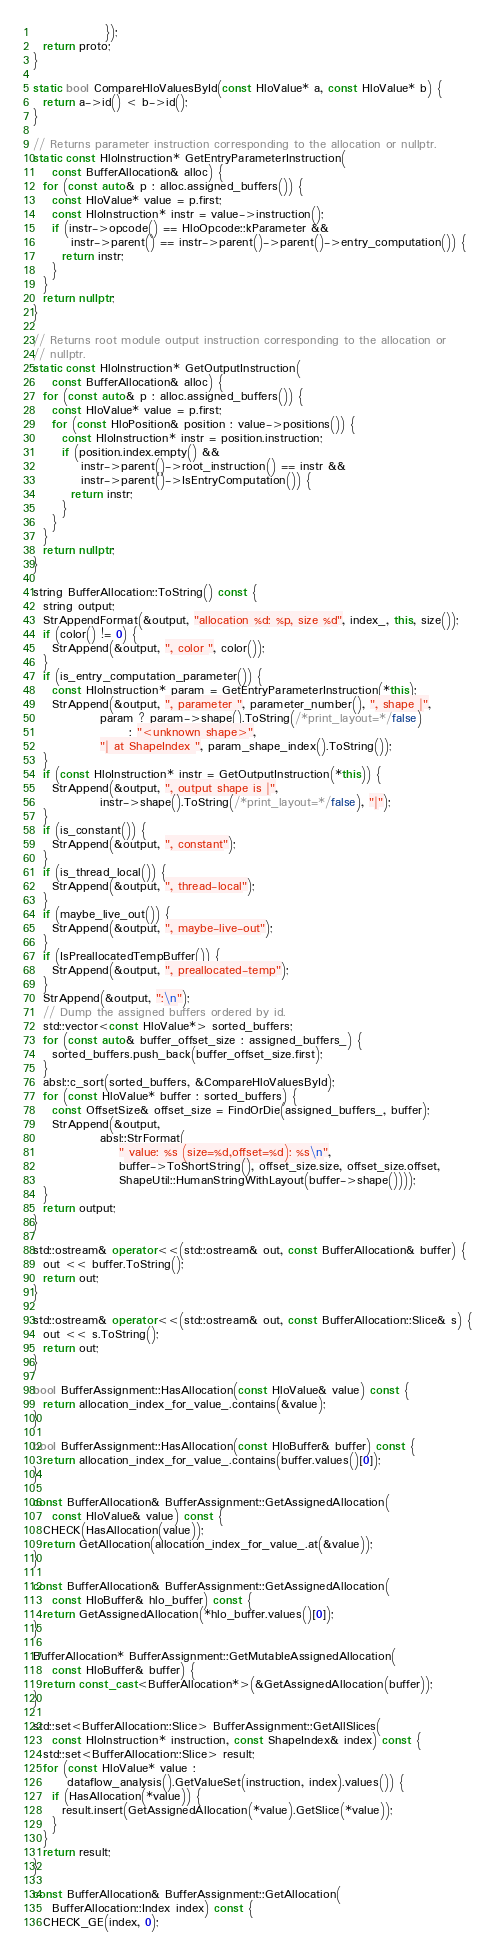<code> <loc_0><loc_0><loc_500><loc_500><_C++_>               });
  return proto;
}

static bool CompareHloValuesById(const HloValue* a, const HloValue* b) {
  return a->id() < b->id();
}

// Returns parameter instruction corresponding to the allocation or nullptr.
static const HloInstruction* GetEntryParameterInstruction(
    const BufferAllocation& alloc) {
  for (const auto& p : alloc.assigned_buffers()) {
    const HloValue* value = p.first;
    const HloInstruction* instr = value->instruction();
    if (instr->opcode() == HloOpcode::kParameter &&
        instr->parent() == instr->parent()->parent()->entry_computation()) {
      return instr;
    }
  }
  return nullptr;
}

// Returns root module output instruction corresponding to the allocation or
// nullptr.
static const HloInstruction* GetOutputInstruction(
    const BufferAllocation& alloc) {
  for (const auto& p : alloc.assigned_buffers()) {
    const HloValue* value = p.first;
    for (const HloPosition& position : value->positions()) {
      const HloInstruction* instr = position.instruction;
      if (position.index.empty() &&
          instr->parent()->root_instruction() == instr &&
          instr->parent()->IsEntryComputation()) {
        return instr;
      }
    }
  }
  return nullptr;
}

string BufferAllocation::ToString() const {
  string output;
  StrAppendFormat(&output, "allocation %d: %p, size %d", index_, this, size());
  if (color() != 0) {
    StrAppend(&output, ", color ", color());
  }
  if (is_entry_computation_parameter()) {
    const HloInstruction* param = GetEntryParameterInstruction(*this);
    StrAppend(&output, ", parameter ", parameter_number(), ", shape |",
              param ? param->shape().ToString(/*print_layout=*/false)
                    : "<unknown shape>",
              "| at ShapeIndex ", param_shape_index().ToString());
  }
  if (const HloInstruction* instr = GetOutputInstruction(*this)) {
    StrAppend(&output, ", output shape is |",
              instr->shape().ToString(/*print_layout=*/false), "|");
  }
  if (is_constant()) {
    StrAppend(&output, ", constant");
  }
  if (is_thread_local()) {
    StrAppend(&output, ", thread-local");
  }
  if (maybe_live_out()) {
    StrAppend(&output, ", maybe-live-out");
  }
  if (IsPreallocatedTempBuffer()) {
    StrAppend(&output, ", preallocated-temp");
  }
  StrAppend(&output, ":\n");
  // Dump the assigned buffers ordered by id.
  std::vector<const HloValue*> sorted_buffers;
  for (const auto& buffer_offset_size : assigned_buffers_) {
    sorted_buffers.push_back(buffer_offset_size.first);
  }
  absl::c_sort(sorted_buffers, &CompareHloValuesById);
  for (const HloValue* buffer : sorted_buffers) {
    const OffsetSize& offset_size = FindOrDie(assigned_buffers_, buffer);
    StrAppend(&output,
              absl::StrFormat(
                  " value: %s (size=%d,offset=%d): %s\n",
                  buffer->ToShortString(), offset_size.size, offset_size.offset,
                  ShapeUtil::HumanStringWithLayout(buffer->shape())));
  }
  return output;
}

std::ostream& operator<<(std::ostream& out, const BufferAllocation& buffer) {
  out << buffer.ToString();
  return out;
}

std::ostream& operator<<(std::ostream& out, const BufferAllocation::Slice& s) {
  out << s.ToString();
  return out;
}

bool BufferAssignment::HasAllocation(const HloValue& value) const {
  return allocation_index_for_value_.contains(&value);
}

bool BufferAssignment::HasAllocation(const HloBuffer& buffer) const {
  return allocation_index_for_value_.contains(buffer.values()[0]);
}

const BufferAllocation& BufferAssignment::GetAssignedAllocation(
    const HloValue& value) const {
  CHECK(HasAllocation(value));
  return GetAllocation(allocation_index_for_value_.at(&value));
}

const BufferAllocation& BufferAssignment::GetAssignedAllocation(
    const HloBuffer& hlo_buffer) const {
  return GetAssignedAllocation(*hlo_buffer.values()[0]);
}

BufferAllocation* BufferAssignment::GetMutableAssignedAllocation(
    const HloBuffer& buffer) {
  return const_cast<BufferAllocation*>(&GetAssignedAllocation(buffer));
}

std::set<BufferAllocation::Slice> BufferAssignment::GetAllSlices(
    const HloInstruction* instruction, const ShapeIndex& index) const {
  std::set<BufferAllocation::Slice> result;
  for (const HloValue* value :
       dataflow_analysis().GetValueSet(instruction, index).values()) {
    if (HasAllocation(*value)) {
      result.insert(GetAssignedAllocation(*value).GetSlice(*value));
    }
  }
  return result;
}

const BufferAllocation& BufferAssignment::GetAllocation(
    BufferAllocation::Index index) const {
  CHECK_GE(index, 0);</code> 